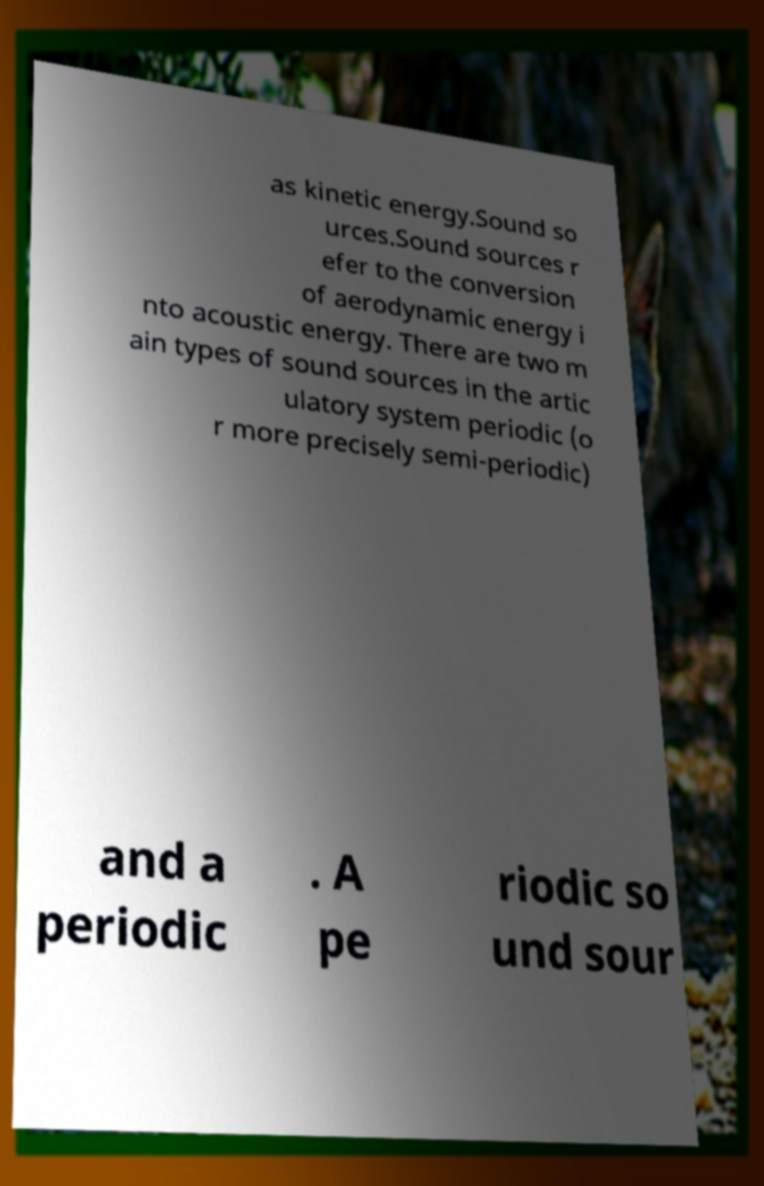For documentation purposes, I need the text within this image transcribed. Could you provide that? as kinetic energy.Sound so urces.Sound sources r efer to the conversion of aerodynamic energy i nto acoustic energy. There are two m ain types of sound sources in the artic ulatory system periodic (o r more precisely semi-periodic) and a periodic . A pe riodic so und sour 